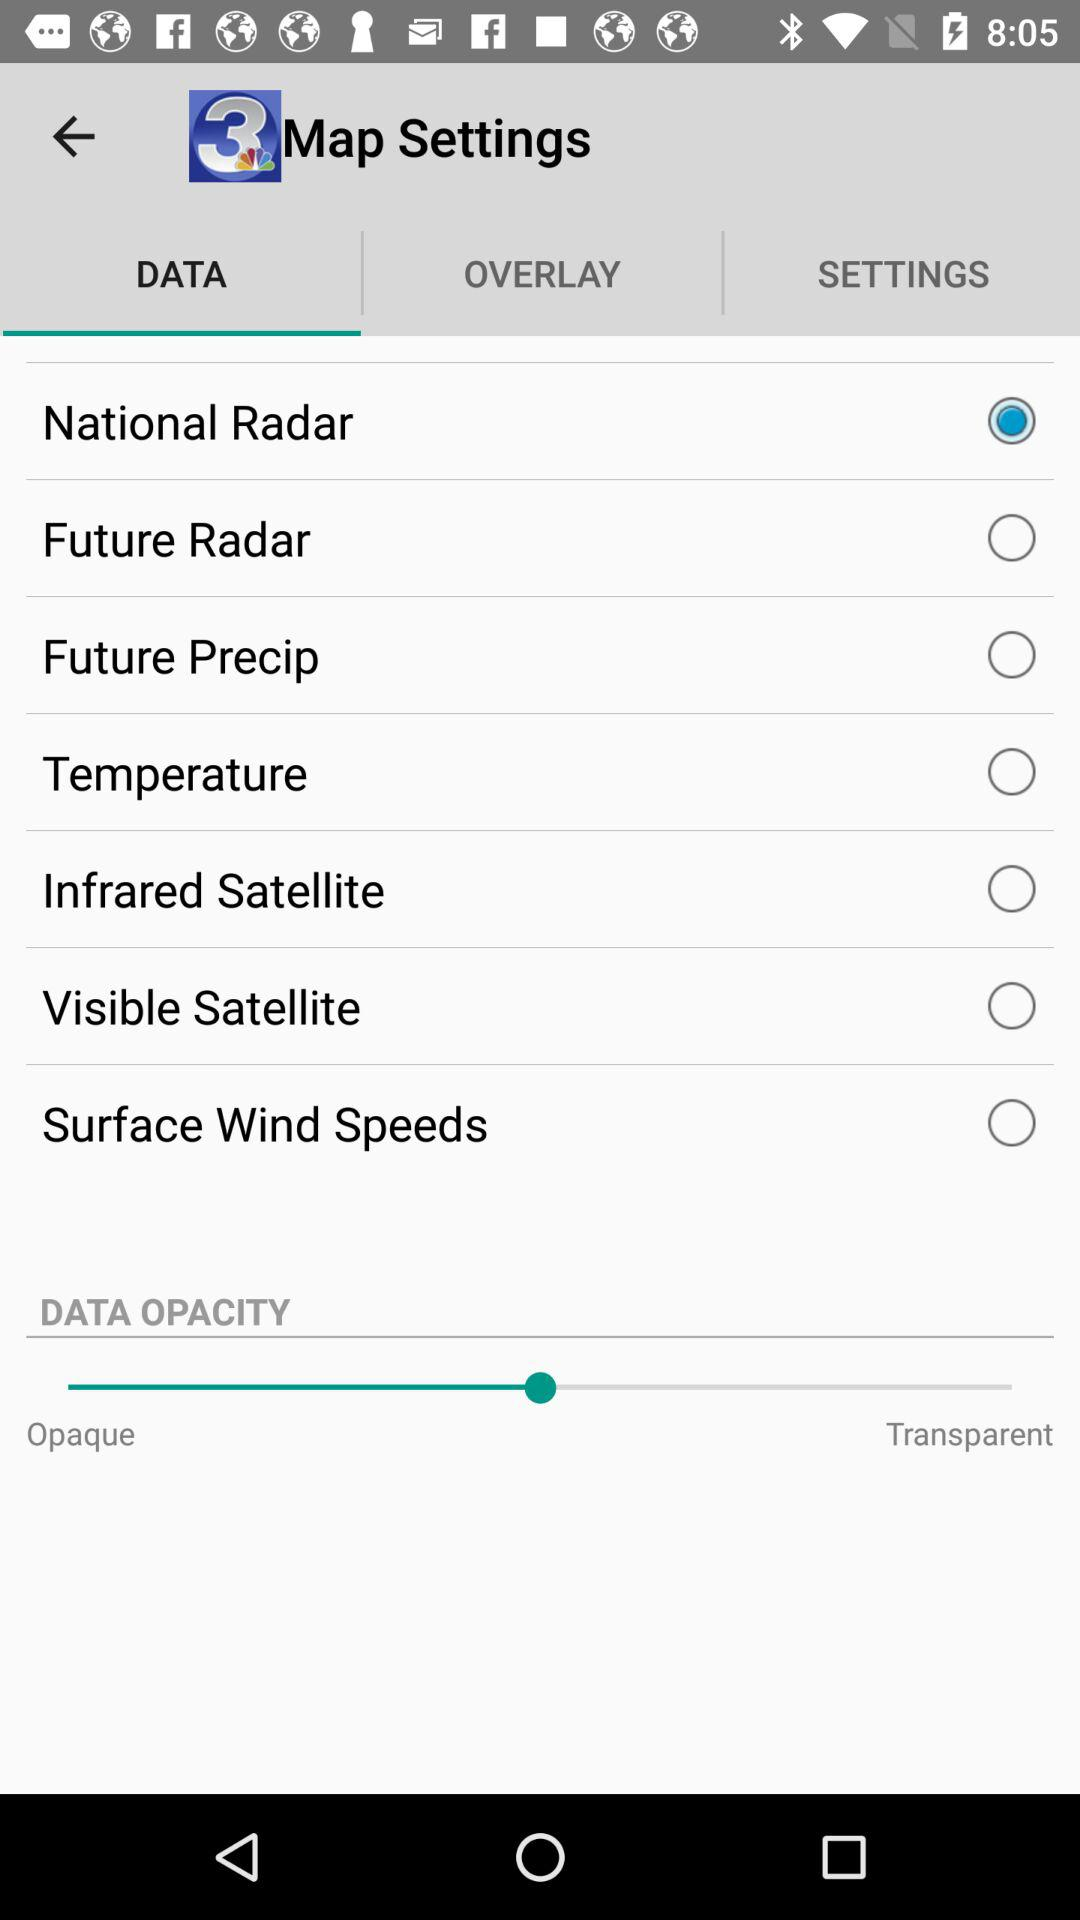Which tab has been selected? The tab that has been selected is "DATA". 